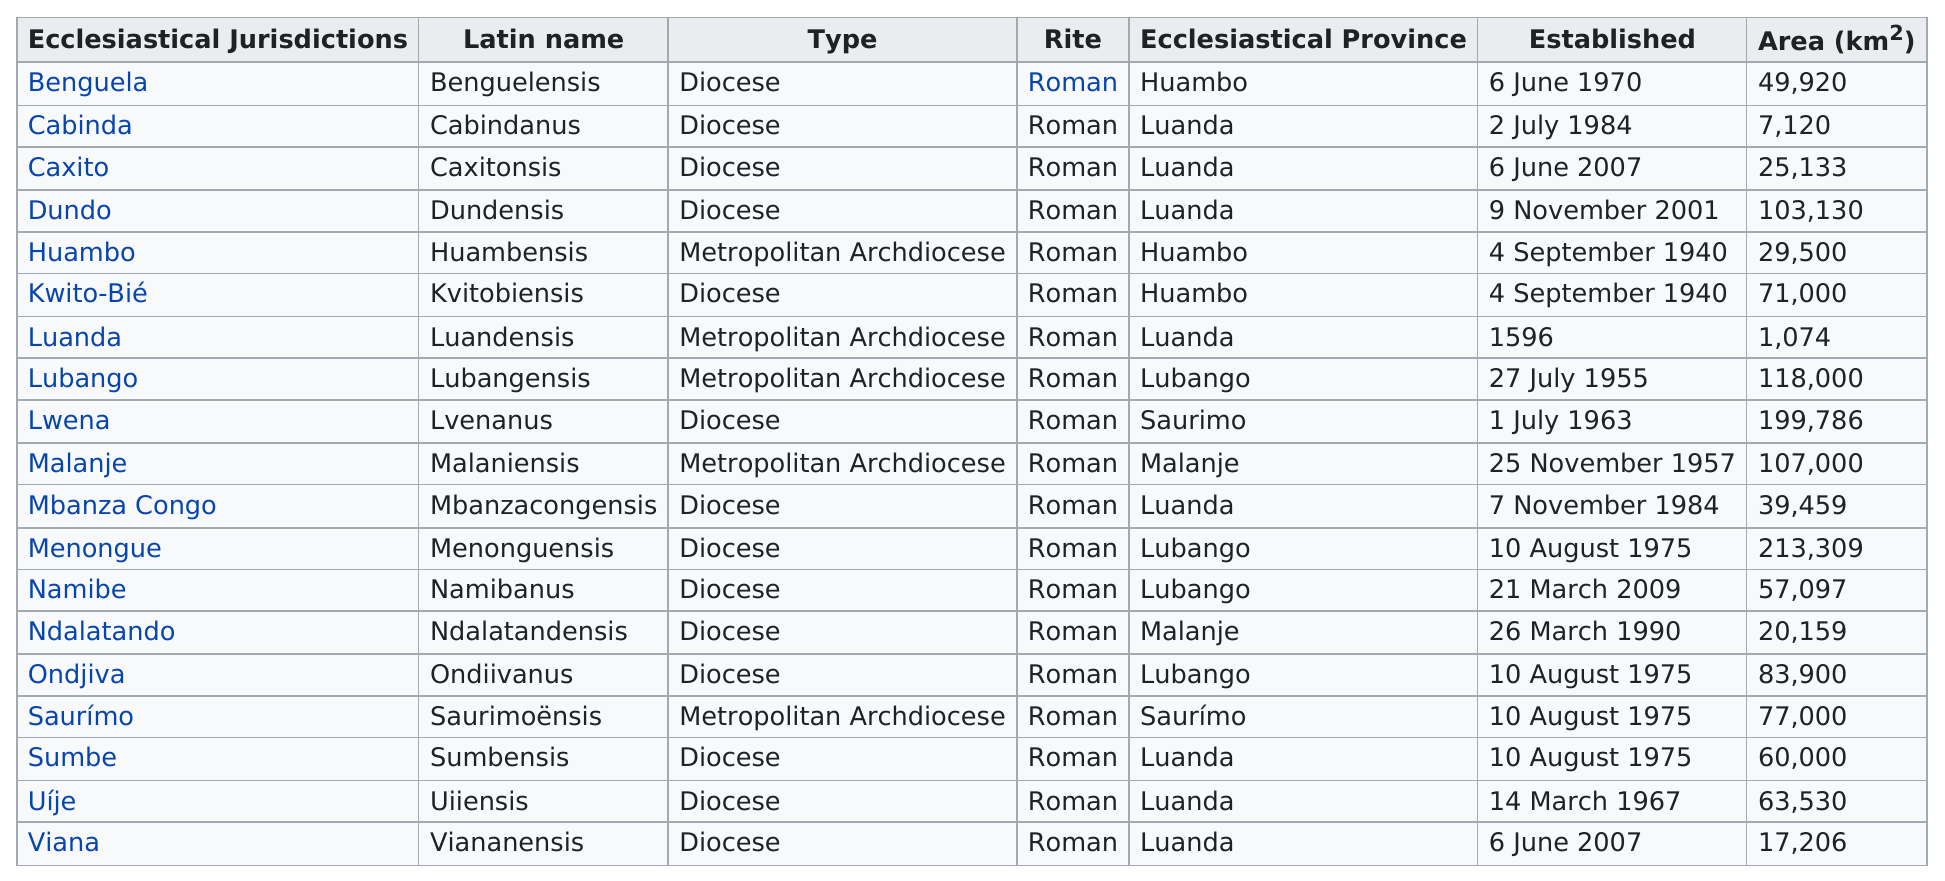Give some essential details in this illustration. For 418 years, the Roman Catholic Diocese of Luandensis has been established in Angola. Before November 5, 1955, the city of Lubango was established. Namibe is the most recent jurisdiction to have been established. There were 14 Roman Catholic dioceses established in Angola before 1990. The diocese with a larger area is Dundo. 